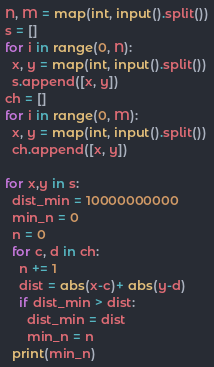Convert code to text. <code><loc_0><loc_0><loc_500><loc_500><_Python_>N, M = map(int, input().split())
s = []
for i in range(0, N):
  x, y = map(int, input().split())
  s.append([x, y])
ch = []
for i in range(0, M):
  x, y = map(int, input().split())
  ch.append([x, y])
  
for x,y in s:
  dist_min = 10000000000
  min_n = 0
  n = 0
  for c, d in ch:
    n += 1
    dist = abs(x-c)+ abs(y-d)
    if dist_min > dist:
      dist_min = dist
      min_n = n
  print(min_n)</code> 